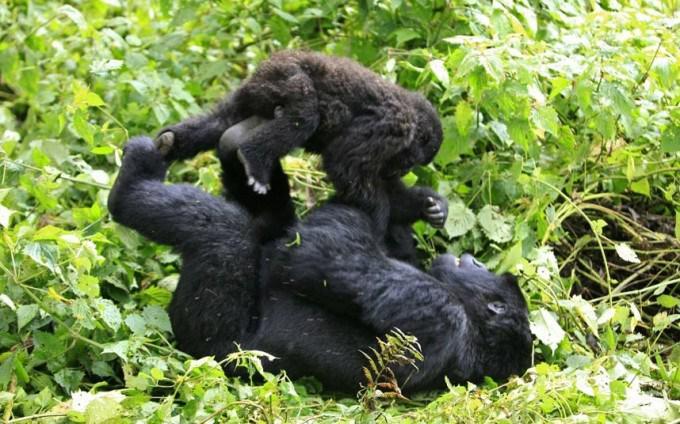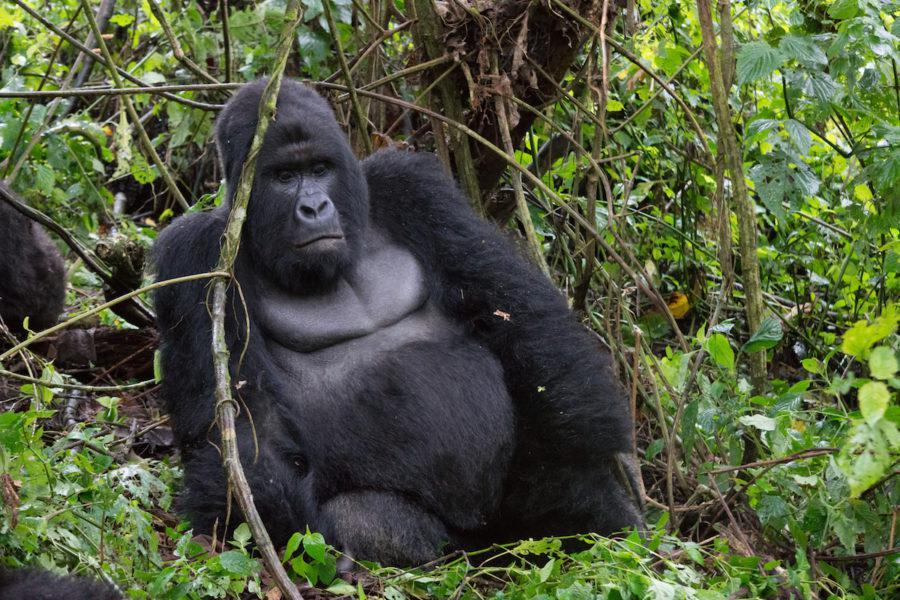The first image is the image on the left, the second image is the image on the right. Evaluate the accuracy of this statement regarding the images: "The small gorilla is on top of the larger one in the image on the left.". Is it true? Answer yes or no. Yes. The first image is the image on the left, the second image is the image on the right. Examine the images to the left and right. Is the description "All of the images have two generations of apes." accurate? Answer yes or no. No. 